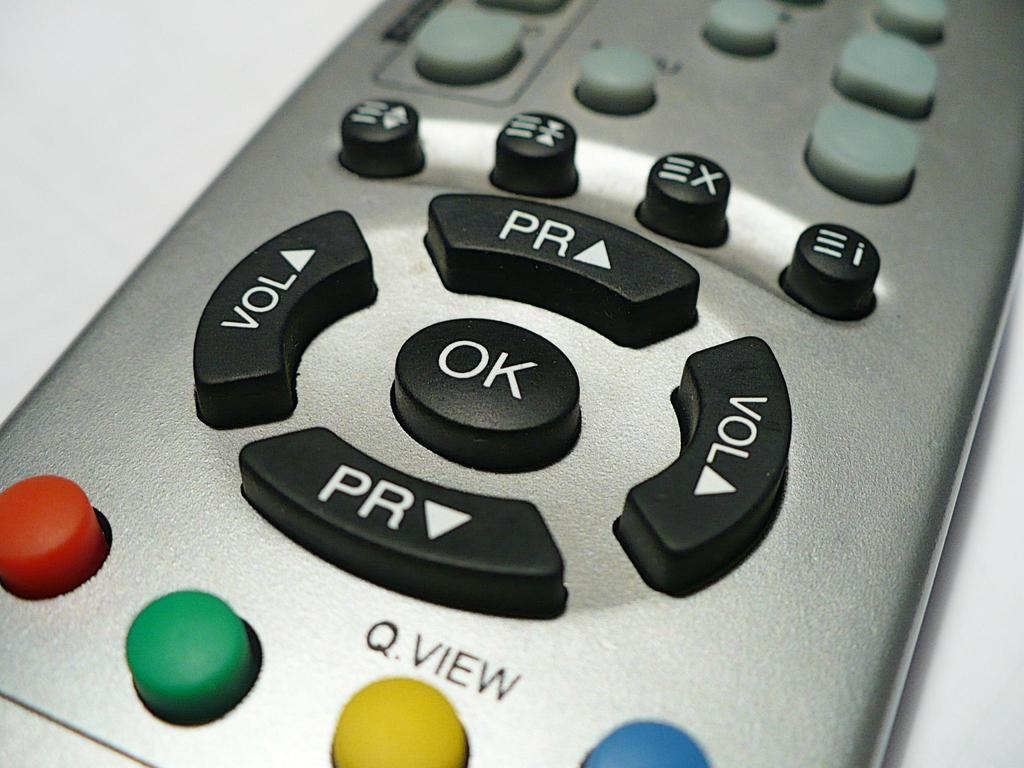<image>
Offer a succinct explanation of the picture presented. Silver remote with a Ok button and Volume button in black. 